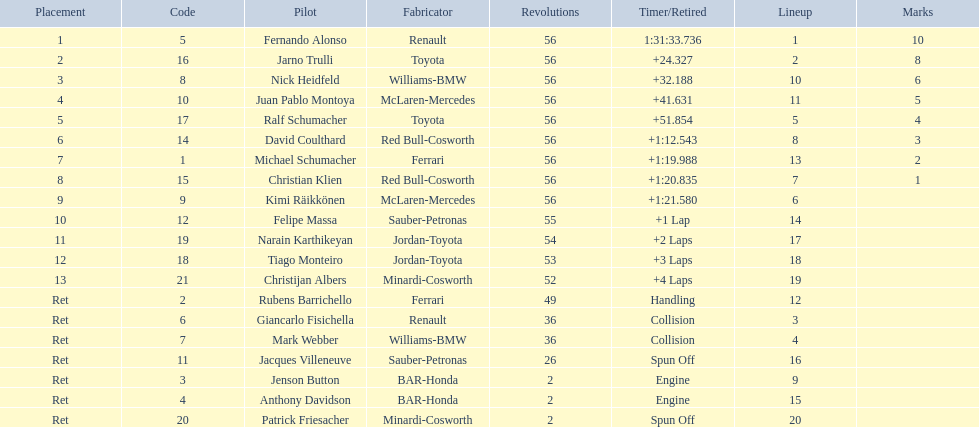Who was fernando alonso's instructor? Renault. How many laps did fernando alonso run? 56. How long did it take alonso to complete the race? 1:31:33.736. 